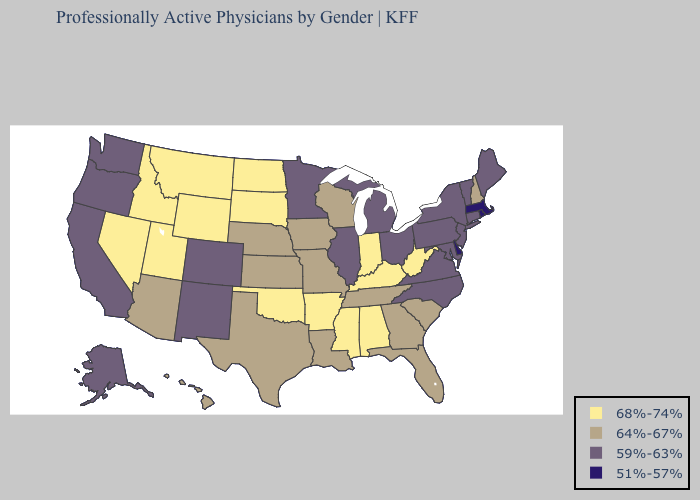Name the states that have a value in the range 68%-74%?
Give a very brief answer. Alabama, Arkansas, Idaho, Indiana, Kentucky, Mississippi, Montana, Nevada, North Dakota, Oklahoma, South Dakota, Utah, West Virginia, Wyoming. Which states have the highest value in the USA?
Be succinct. Alabama, Arkansas, Idaho, Indiana, Kentucky, Mississippi, Montana, Nevada, North Dakota, Oklahoma, South Dakota, Utah, West Virginia, Wyoming. Among the states that border Indiana , which have the highest value?
Concise answer only. Kentucky. Does Wyoming have the lowest value in the West?
Keep it brief. No. Name the states that have a value in the range 64%-67%?
Be succinct. Arizona, Florida, Georgia, Hawaii, Iowa, Kansas, Louisiana, Missouri, Nebraska, New Hampshire, South Carolina, Tennessee, Texas, Wisconsin. Does Montana have a higher value than Oklahoma?
Keep it brief. No. What is the highest value in the USA?
Quick response, please. 68%-74%. What is the value of Colorado?
Quick response, please. 59%-63%. Does New Hampshire have the highest value in the Northeast?
Be succinct. Yes. Name the states that have a value in the range 64%-67%?
Keep it brief. Arizona, Florida, Georgia, Hawaii, Iowa, Kansas, Louisiana, Missouri, Nebraska, New Hampshire, South Carolina, Tennessee, Texas, Wisconsin. Name the states that have a value in the range 68%-74%?
Keep it brief. Alabama, Arkansas, Idaho, Indiana, Kentucky, Mississippi, Montana, Nevada, North Dakota, Oklahoma, South Dakota, Utah, West Virginia, Wyoming. Name the states that have a value in the range 64%-67%?
Short answer required. Arizona, Florida, Georgia, Hawaii, Iowa, Kansas, Louisiana, Missouri, Nebraska, New Hampshire, South Carolina, Tennessee, Texas, Wisconsin. Name the states that have a value in the range 51%-57%?
Give a very brief answer. Delaware, Massachusetts, Rhode Island. Name the states that have a value in the range 68%-74%?
Write a very short answer. Alabama, Arkansas, Idaho, Indiana, Kentucky, Mississippi, Montana, Nevada, North Dakota, Oklahoma, South Dakota, Utah, West Virginia, Wyoming. What is the value of Minnesota?
Short answer required. 59%-63%. 